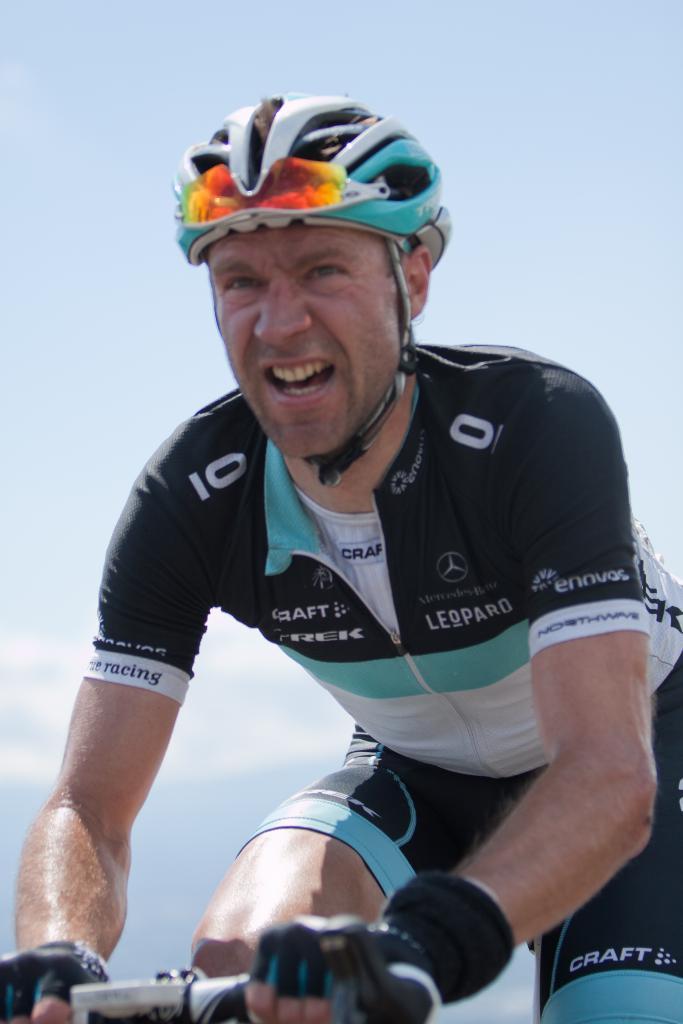Can you describe this image briefly? In this picture man is riding a bicycle wearing a helmet. 